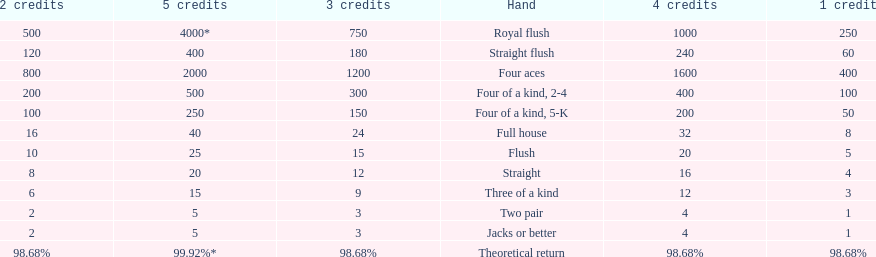Each four aces win is a multiple of what number? 400. 